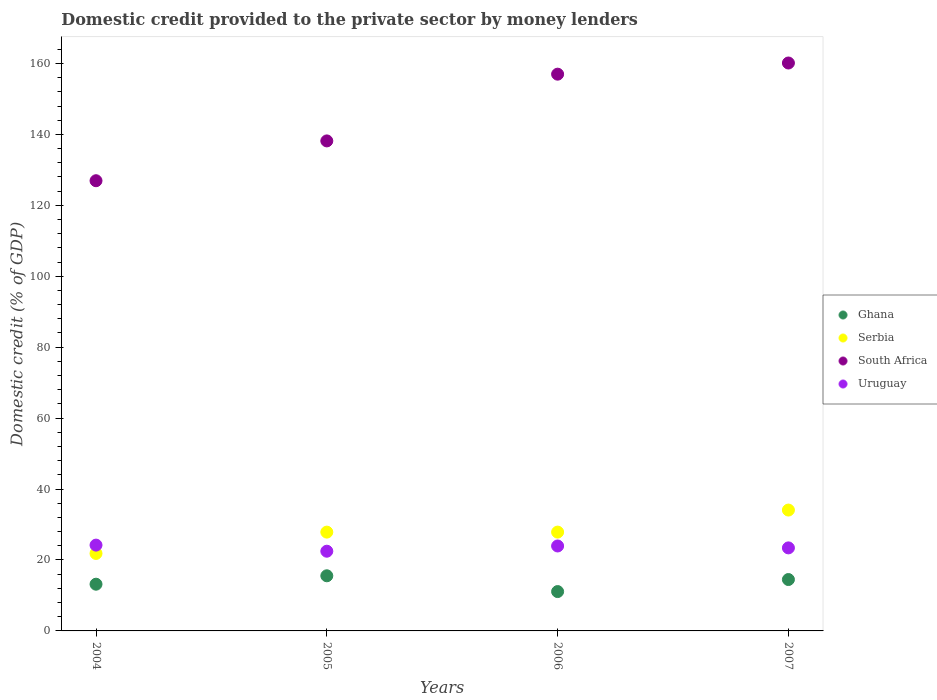Is the number of dotlines equal to the number of legend labels?
Your answer should be compact. Yes. What is the domestic credit provided to the private sector by money lenders in Uruguay in 2004?
Provide a short and direct response. 24.19. Across all years, what is the maximum domestic credit provided to the private sector by money lenders in South Africa?
Your answer should be very brief. 160.12. Across all years, what is the minimum domestic credit provided to the private sector by money lenders in Uruguay?
Keep it short and to the point. 22.47. What is the total domestic credit provided to the private sector by money lenders in South Africa in the graph?
Keep it short and to the point. 582.19. What is the difference between the domestic credit provided to the private sector by money lenders in Uruguay in 2005 and that in 2007?
Give a very brief answer. -0.94. What is the difference between the domestic credit provided to the private sector by money lenders in Serbia in 2006 and the domestic credit provided to the private sector by money lenders in Ghana in 2004?
Your response must be concise. 14.69. What is the average domestic credit provided to the private sector by money lenders in Uruguay per year?
Your response must be concise. 23.51. In the year 2004, what is the difference between the domestic credit provided to the private sector by money lenders in Ghana and domestic credit provided to the private sector by money lenders in Serbia?
Offer a terse response. -8.67. In how many years, is the domestic credit provided to the private sector by money lenders in Serbia greater than 44 %?
Provide a succinct answer. 0. What is the ratio of the domestic credit provided to the private sector by money lenders in South Africa in 2004 to that in 2006?
Keep it short and to the point. 0.81. Is the domestic credit provided to the private sector by money lenders in Serbia in 2006 less than that in 2007?
Your answer should be very brief. Yes. What is the difference between the highest and the second highest domestic credit provided to the private sector by money lenders in Serbia?
Keep it short and to the point. 6.21. What is the difference between the highest and the lowest domestic credit provided to the private sector by money lenders in South Africa?
Keep it short and to the point. 33.19. Is it the case that in every year, the sum of the domestic credit provided to the private sector by money lenders in Ghana and domestic credit provided to the private sector by money lenders in Uruguay  is greater than the sum of domestic credit provided to the private sector by money lenders in South Africa and domestic credit provided to the private sector by money lenders in Serbia?
Give a very brief answer. No. How many dotlines are there?
Offer a very short reply. 4. Are the values on the major ticks of Y-axis written in scientific E-notation?
Provide a succinct answer. No. Does the graph contain any zero values?
Keep it short and to the point. No. Does the graph contain grids?
Keep it short and to the point. No. Where does the legend appear in the graph?
Your response must be concise. Center right. How are the legend labels stacked?
Provide a succinct answer. Vertical. What is the title of the graph?
Offer a very short reply. Domestic credit provided to the private sector by money lenders. Does "Turkey" appear as one of the legend labels in the graph?
Provide a short and direct response. No. What is the label or title of the X-axis?
Give a very brief answer. Years. What is the label or title of the Y-axis?
Your response must be concise. Domestic credit (% of GDP). What is the Domestic credit (% of GDP) in Ghana in 2004?
Provide a succinct answer. 13.17. What is the Domestic credit (% of GDP) of Serbia in 2004?
Ensure brevity in your answer.  21.84. What is the Domestic credit (% of GDP) in South Africa in 2004?
Keep it short and to the point. 126.93. What is the Domestic credit (% of GDP) in Uruguay in 2004?
Make the answer very short. 24.19. What is the Domestic credit (% of GDP) of Ghana in 2005?
Offer a very short reply. 15.54. What is the Domestic credit (% of GDP) in Serbia in 2005?
Ensure brevity in your answer.  27.86. What is the Domestic credit (% of GDP) of South Africa in 2005?
Give a very brief answer. 138.16. What is the Domestic credit (% of GDP) of Uruguay in 2005?
Provide a succinct answer. 22.47. What is the Domestic credit (% of GDP) in Ghana in 2006?
Offer a very short reply. 11.09. What is the Domestic credit (% of GDP) of Serbia in 2006?
Ensure brevity in your answer.  27.86. What is the Domestic credit (% of GDP) of South Africa in 2006?
Offer a terse response. 156.98. What is the Domestic credit (% of GDP) of Uruguay in 2006?
Ensure brevity in your answer.  23.95. What is the Domestic credit (% of GDP) of Ghana in 2007?
Your answer should be very brief. 14.49. What is the Domestic credit (% of GDP) in Serbia in 2007?
Give a very brief answer. 34.08. What is the Domestic credit (% of GDP) in South Africa in 2007?
Offer a terse response. 160.12. What is the Domestic credit (% of GDP) of Uruguay in 2007?
Provide a short and direct response. 23.41. Across all years, what is the maximum Domestic credit (% of GDP) in Ghana?
Keep it short and to the point. 15.54. Across all years, what is the maximum Domestic credit (% of GDP) of Serbia?
Provide a succinct answer. 34.08. Across all years, what is the maximum Domestic credit (% of GDP) in South Africa?
Your answer should be compact. 160.12. Across all years, what is the maximum Domestic credit (% of GDP) of Uruguay?
Give a very brief answer. 24.19. Across all years, what is the minimum Domestic credit (% of GDP) in Ghana?
Keep it short and to the point. 11.09. Across all years, what is the minimum Domestic credit (% of GDP) of Serbia?
Provide a succinct answer. 21.84. Across all years, what is the minimum Domestic credit (% of GDP) in South Africa?
Your response must be concise. 126.93. Across all years, what is the minimum Domestic credit (% of GDP) in Uruguay?
Ensure brevity in your answer.  22.47. What is the total Domestic credit (% of GDP) of Ghana in the graph?
Give a very brief answer. 54.3. What is the total Domestic credit (% of GDP) in Serbia in the graph?
Your answer should be very brief. 111.64. What is the total Domestic credit (% of GDP) of South Africa in the graph?
Offer a terse response. 582.19. What is the total Domestic credit (% of GDP) in Uruguay in the graph?
Give a very brief answer. 94.03. What is the difference between the Domestic credit (% of GDP) of Ghana in 2004 and that in 2005?
Offer a terse response. -2.37. What is the difference between the Domestic credit (% of GDP) in Serbia in 2004 and that in 2005?
Provide a succinct answer. -6.01. What is the difference between the Domestic credit (% of GDP) in South Africa in 2004 and that in 2005?
Make the answer very short. -11.23. What is the difference between the Domestic credit (% of GDP) in Uruguay in 2004 and that in 2005?
Ensure brevity in your answer.  1.72. What is the difference between the Domestic credit (% of GDP) of Ghana in 2004 and that in 2006?
Provide a succinct answer. 2.08. What is the difference between the Domestic credit (% of GDP) of Serbia in 2004 and that in 2006?
Provide a succinct answer. -6.02. What is the difference between the Domestic credit (% of GDP) of South Africa in 2004 and that in 2006?
Your answer should be very brief. -30.04. What is the difference between the Domestic credit (% of GDP) of Uruguay in 2004 and that in 2006?
Give a very brief answer. 0.24. What is the difference between the Domestic credit (% of GDP) in Ghana in 2004 and that in 2007?
Offer a very short reply. -1.32. What is the difference between the Domestic credit (% of GDP) in Serbia in 2004 and that in 2007?
Keep it short and to the point. -12.24. What is the difference between the Domestic credit (% of GDP) of South Africa in 2004 and that in 2007?
Keep it short and to the point. -33.19. What is the difference between the Domestic credit (% of GDP) of Uruguay in 2004 and that in 2007?
Your response must be concise. 0.78. What is the difference between the Domestic credit (% of GDP) in Ghana in 2005 and that in 2006?
Give a very brief answer. 4.45. What is the difference between the Domestic credit (% of GDP) in Serbia in 2005 and that in 2006?
Your answer should be compact. -0.01. What is the difference between the Domestic credit (% of GDP) in South Africa in 2005 and that in 2006?
Provide a succinct answer. -18.82. What is the difference between the Domestic credit (% of GDP) of Uruguay in 2005 and that in 2006?
Provide a short and direct response. -1.47. What is the difference between the Domestic credit (% of GDP) of Ghana in 2005 and that in 2007?
Provide a succinct answer. 1.06. What is the difference between the Domestic credit (% of GDP) of Serbia in 2005 and that in 2007?
Give a very brief answer. -6.22. What is the difference between the Domestic credit (% of GDP) in South Africa in 2005 and that in 2007?
Provide a short and direct response. -21.97. What is the difference between the Domestic credit (% of GDP) in Uruguay in 2005 and that in 2007?
Give a very brief answer. -0.94. What is the difference between the Domestic credit (% of GDP) in Ghana in 2006 and that in 2007?
Your answer should be compact. -3.39. What is the difference between the Domestic credit (% of GDP) of Serbia in 2006 and that in 2007?
Give a very brief answer. -6.21. What is the difference between the Domestic credit (% of GDP) of South Africa in 2006 and that in 2007?
Your answer should be compact. -3.15. What is the difference between the Domestic credit (% of GDP) in Uruguay in 2006 and that in 2007?
Give a very brief answer. 0.54. What is the difference between the Domestic credit (% of GDP) in Ghana in 2004 and the Domestic credit (% of GDP) in Serbia in 2005?
Ensure brevity in your answer.  -14.68. What is the difference between the Domestic credit (% of GDP) in Ghana in 2004 and the Domestic credit (% of GDP) in South Africa in 2005?
Ensure brevity in your answer.  -124.99. What is the difference between the Domestic credit (% of GDP) of Ghana in 2004 and the Domestic credit (% of GDP) of Uruguay in 2005?
Offer a terse response. -9.3. What is the difference between the Domestic credit (% of GDP) in Serbia in 2004 and the Domestic credit (% of GDP) in South Africa in 2005?
Make the answer very short. -116.32. What is the difference between the Domestic credit (% of GDP) of Serbia in 2004 and the Domestic credit (% of GDP) of Uruguay in 2005?
Your answer should be compact. -0.63. What is the difference between the Domestic credit (% of GDP) of South Africa in 2004 and the Domestic credit (% of GDP) of Uruguay in 2005?
Provide a short and direct response. 104.46. What is the difference between the Domestic credit (% of GDP) in Ghana in 2004 and the Domestic credit (% of GDP) in Serbia in 2006?
Your answer should be compact. -14.69. What is the difference between the Domestic credit (% of GDP) in Ghana in 2004 and the Domestic credit (% of GDP) in South Africa in 2006?
Keep it short and to the point. -143.8. What is the difference between the Domestic credit (% of GDP) of Ghana in 2004 and the Domestic credit (% of GDP) of Uruguay in 2006?
Your answer should be very brief. -10.78. What is the difference between the Domestic credit (% of GDP) in Serbia in 2004 and the Domestic credit (% of GDP) in South Africa in 2006?
Provide a succinct answer. -135.13. What is the difference between the Domestic credit (% of GDP) of Serbia in 2004 and the Domestic credit (% of GDP) of Uruguay in 2006?
Keep it short and to the point. -2.11. What is the difference between the Domestic credit (% of GDP) of South Africa in 2004 and the Domestic credit (% of GDP) of Uruguay in 2006?
Provide a succinct answer. 102.98. What is the difference between the Domestic credit (% of GDP) in Ghana in 2004 and the Domestic credit (% of GDP) in Serbia in 2007?
Keep it short and to the point. -20.9. What is the difference between the Domestic credit (% of GDP) in Ghana in 2004 and the Domestic credit (% of GDP) in South Africa in 2007?
Give a very brief answer. -146.95. What is the difference between the Domestic credit (% of GDP) in Ghana in 2004 and the Domestic credit (% of GDP) in Uruguay in 2007?
Ensure brevity in your answer.  -10.24. What is the difference between the Domestic credit (% of GDP) of Serbia in 2004 and the Domestic credit (% of GDP) of South Africa in 2007?
Keep it short and to the point. -138.28. What is the difference between the Domestic credit (% of GDP) of Serbia in 2004 and the Domestic credit (% of GDP) of Uruguay in 2007?
Give a very brief answer. -1.57. What is the difference between the Domestic credit (% of GDP) of South Africa in 2004 and the Domestic credit (% of GDP) of Uruguay in 2007?
Your answer should be very brief. 103.52. What is the difference between the Domestic credit (% of GDP) in Ghana in 2005 and the Domestic credit (% of GDP) in Serbia in 2006?
Offer a very short reply. -12.32. What is the difference between the Domestic credit (% of GDP) in Ghana in 2005 and the Domestic credit (% of GDP) in South Africa in 2006?
Give a very brief answer. -141.43. What is the difference between the Domestic credit (% of GDP) of Ghana in 2005 and the Domestic credit (% of GDP) of Uruguay in 2006?
Keep it short and to the point. -8.4. What is the difference between the Domestic credit (% of GDP) of Serbia in 2005 and the Domestic credit (% of GDP) of South Africa in 2006?
Make the answer very short. -129.12. What is the difference between the Domestic credit (% of GDP) of Serbia in 2005 and the Domestic credit (% of GDP) of Uruguay in 2006?
Your answer should be very brief. 3.91. What is the difference between the Domestic credit (% of GDP) of South Africa in 2005 and the Domestic credit (% of GDP) of Uruguay in 2006?
Give a very brief answer. 114.21. What is the difference between the Domestic credit (% of GDP) in Ghana in 2005 and the Domestic credit (% of GDP) in Serbia in 2007?
Provide a short and direct response. -18.53. What is the difference between the Domestic credit (% of GDP) of Ghana in 2005 and the Domestic credit (% of GDP) of South Africa in 2007?
Provide a short and direct response. -144.58. What is the difference between the Domestic credit (% of GDP) in Ghana in 2005 and the Domestic credit (% of GDP) in Uruguay in 2007?
Ensure brevity in your answer.  -7.87. What is the difference between the Domestic credit (% of GDP) of Serbia in 2005 and the Domestic credit (% of GDP) of South Africa in 2007?
Your response must be concise. -132.27. What is the difference between the Domestic credit (% of GDP) in Serbia in 2005 and the Domestic credit (% of GDP) in Uruguay in 2007?
Your answer should be compact. 4.45. What is the difference between the Domestic credit (% of GDP) in South Africa in 2005 and the Domestic credit (% of GDP) in Uruguay in 2007?
Your answer should be compact. 114.75. What is the difference between the Domestic credit (% of GDP) in Ghana in 2006 and the Domestic credit (% of GDP) in Serbia in 2007?
Your answer should be very brief. -22.98. What is the difference between the Domestic credit (% of GDP) in Ghana in 2006 and the Domestic credit (% of GDP) in South Africa in 2007?
Offer a terse response. -149.03. What is the difference between the Domestic credit (% of GDP) in Ghana in 2006 and the Domestic credit (% of GDP) in Uruguay in 2007?
Your answer should be compact. -12.32. What is the difference between the Domestic credit (% of GDP) of Serbia in 2006 and the Domestic credit (% of GDP) of South Africa in 2007?
Provide a succinct answer. -132.26. What is the difference between the Domestic credit (% of GDP) of Serbia in 2006 and the Domestic credit (% of GDP) of Uruguay in 2007?
Provide a short and direct response. 4.45. What is the difference between the Domestic credit (% of GDP) of South Africa in 2006 and the Domestic credit (% of GDP) of Uruguay in 2007?
Your answer should be very brief. 133.57. What is the average Domestic credit (% of GDP) in Ghana per year?
Offer a terse response. 13.57. What is the average Domestic credit (% of GDP) of Serbia per year?
Provide a short and direct response. 27.91. What is the average Domestic credit (% of GDP) in South Africa per year?
Provide a short and direct response. 145.55. What is the average Domestic credit (% of GDP) of Uruguay per year?
Your response must be concise. 23.51. In the year 2004, what is the difference between the Domestic credit (% of GDP) in Ghana and Domestic credit (% of GDP) in Serbia?
Provide a short and direct response. -8.67. In the year 2004, what is the difference between the Domestic credit (% of GDP) of Ghana and Domestic credit (% of GDP) of South Africa?
Your answer should be compact. -113.76. In the year 2004, what is the difference between the Domestic credit (% of GDP) of Ghana and Domestic credit (% of GDP) of Uruguay?
Keep it short and to the point. -11.02. In the year 2004, what is the difference between the Domestic credit (% of GDP) in Serbia and Domestic credit (% of GDP) in South Africa?
Your answer should be compact. -105.09. In the year 2004, what is the difference between the Domestic credit (% of GDP) of Serbia and Domestic credit (% of GDP) of Uruguay?
Offer a terse response. -2.35. In the year 2004, what is the difference between the Domestic credit (% of GDP) of South Africa and Domestic credit (% of GDP) of Uruguay?
Give a very brief answer. 102.74. In the year 2005, what is the difference between the Domestic credit (% of GDP) of Ghana and Domestic credit (% of GDP) of Serbia?
Your answer should be very brief. -12.31. In the year 2005, what is the difference between the Domestic credit (% of GDP) of Ghana and Domestic credit (% of GDP) of South Africa?
Give a very brief answer. -122.62. In the year 2005, what is the difference between the Domestic credit (% of GDP) in Ghana and Domestic credit (% of GDP) in Uruguay?
Give a very brief answer. -6.93. In the year 2005, what is the difference between the Domestic credit (% of GDP) in Serbia and Domestic credit (% of GDP) in South Africa?
Provide a succinct answer. -110.3. In the year 2005, what is the difference between the Domestic credit (% of GDP) of Serbia and Domestic credit (% of GDP) of Uruguay?
Keep it short and to the point. 5.38. In the year 2005, what is the difference between the Domestic credit (% of GDP) in South Africa and Domestic credit (% of GDP) in Uruguay?
Provide a short and direct response. 115.68. In the year 2006, what is the difference between the Domestic credit (% of GDP) in Ghana and Domestic credit (% of GDP) in Serbia?
Ensure brevity in your answer.  -16.77. In the year 2006, what is the difference between the Domestic credit (% of GDP) in Ghana and Domestic credit (% of GDP) in South Africa?
Give a very brief answer. -145.88. In the year 2006, what is the difference between the Domestic credit (% of GDP) of Ghana and Domestic credit (% of GDP) of Uruguay?
Your answer should be compact. -12.85. In the year 2006, what is the difference between the Domestic credit (% of GDP) in Serbia and Domestic credit (% of GDP) in South Africa?
Make the answer very short. -129.11. In the year 2006, what is the difference between the Domestic credit (% of GDP) of Serbia and Domestic credit (% of GDP) of Uruguay?
Your response must be concise. 3.91. In the year 2006, what is the difference between the Domestic credit (% of GDP) in South Africa and Domestic credit (% of GDP) in Uruguay?
Provide a short and direct response. 133.03. In the year 2007, what is the difference between the Domestic credit (% of GDP) in Ghana and Domestic credit (% of GDP) in Serbia?
Keep it short and to the point. -19.59. In the year 2007, what is the difference between the Domestic credit (% of GDP) in Ghana and Domestic credit (% of GDP) in South Africa?
Make the answer very short. -145.64. In the year 2007, what is the difference between the Domestic credit (% of GDP) of Ghana and Domestic credit (% of GDP) of Uruguay?
Keep it short and to the point. -8.92. In the year 2007, what is the difference between the Domestic credit (% of GDP) of Serbia and Domestic credit (% of GDP) of South Africa?
Offer a very short reply. -126.05. In the year 2007, what is the difference between the Domestic credit (% of GDP) in Serbia and Domestic credit (% of GDP) in Uruguay?
Offer a very short reply. 10.67. In the year 2007, what is the difference between the Domestic credit (% of GDP) in South Africa and Domestic credit (% of GDP) in Uruguay?
Your answer should be very brief. 136.71. What is the ratio of the Domestic credit (% of GDP) in Ghana in 2004 to that in 2005?
Provide a succinct answer. 0.85. What is the ratio of the Domestic credit (% of GDP) in Serbia in 2004 to that in 2005?
Offer a terse response. 0.78. What is the ratio of the Domestic credit (% of GDP) in South Africa in 2004 to that in 2005?
Ensure brevity in your answer.  0.92. What is the ratio of the Domestic credit (% of GDP) of Uruguay in 2004 to that in 2005?
Give a very brief answer. 1.08. What is the ratio of the Domestic credit (% of GDP) of Ghana in 2004 to that in 2006?
Provide a succinct answer. 1.19. What is the ratio of the Domestic credit (% of GDP) in Serbia in 2004 to that in 2006?
Offer a very short reply. 0.78. What is the ratio of the Domestic credit (% of GDP) in South Africa in 2004 to that in 2006?
Offer a very short reply. 0.81. What is the ratio of the Domestic credit (% of GDP) of Uruguay in 2004 to that in 2006?
Make the answer very short. 1.01. What is the ratio of the Domestic credit (% of GDP) of Ghana in 2004 to that in 2007?
Give a very brief answer. 0.91. What is the ratio of the Domestic credit (% of GDP) in Serbia in 2004 to that in 2007?
Make the answer very short. 0.64. What is the ratio of the Domestic credit (% of GDP) in South Africa in 2004 to that in 2007?
Give a very brief answer. 0.79. What is the ratio of the Domestic credit (% of GDP) of Uruguay in 2004 to that in 2007?
Your answer should be compact. 1.03. What is the ratio of the Domestic credit (% of GDP) of Ghana in 2005 to that in 2006?
Provide a succinct answer. 1.4. What is the ratio of the Domestic credit (% of GDP) in South Africa in 2005 to that in 2006?
Your answer should be very brief. 0.88. What is the ratio of the Domestic credit (% of GDP) in Uruguay in 2005 to that in 2006?
Offer a very short reply. 0.94. What is the ratio of the Domestic credit (% of GDP) of Ghana in 2005 to that in 2007?
Your answer should be very brief. 1.07. What is the ratio of the Domestic credit (% of GDP) in Serbia in 2005 to that in 2007?
Offer a very short reply. 0.82. What is the ratio of the Domestic credit (% of GDP) of South Africa in 2005 to that in 2007?
Offer a very short reply. 0.86. What is the ratio of the Domestic credit (% of GDP) in Ghana in 2006 to that in 2007?
Keep it short and to the point. 0.77. What is the ratio of the Domestic credit (% of GDP) in Serbia in 2006 to that in 2007?
Offer a terse response. 0.82. What is the ratio of the Domestic credit (% of GDP) of South Africa in 2006 to that in 2007?
Offer a terse response. 0.98. What is the difference between the highest and the second highest Domestic credit (% of GDP) of Ghana?
Your response must be concise. 1.06. What is the difference between the highest and the second highest Domestic credit (% of GDP) of Serbia?
Your answer should be very brief. 6.21. What is the difference between the highest and the second highest Domestic credit (% of GDP) in South Africa?
Offer a very short reply. 3.15. What is the difference between the highest and the second highest Domestic credit (% of GDP) of Uruguay?
Offer a very short reply. 0.24. What is the difference between the highest and the lowest Domestic credit (% of GDP) in Ghana?
Make the answer very short. 4.45. What is the difference between the highest and the lowest Domestic credit (% of GDP) in Serbia?
Offer a very short reply. 12.24. What is the difference between the highest and the lowest Domestic credit (% of GDP) of South Africa?
Offer a terse response. 33.19. What is the difference between the highest and the lowest Domestic credit (% of GDP) of Uruguay?
Ensure brevity in your answer.  1.72. 